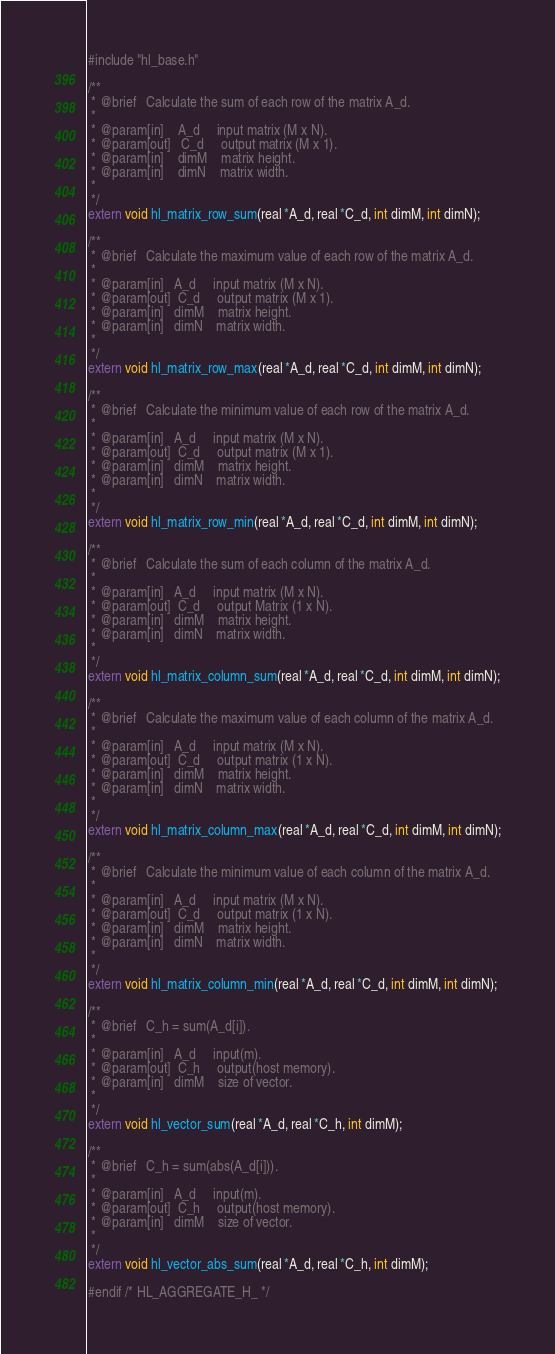Convert code to text. <code><loc_0><loc_0><loc_500><loc_500><_C_>#include "hl_base.h"

/**
 * @brief   Calculate the sum of each row of the matrix A_d.
 *
 * @param[in]    A_d     input matrix (M x N).
 * @param[out]   C_d     output matrix (M x 1).
 * @param[in]    dimM    matrix height.
 * @param[in]    dimN    matrix width.
 *
 */
extern void hl_matrix_row_sum(real *A_d, real *C_d, int dimM, int dimN);

/**
 * @brief   Calculate the maximum value of each row of the matrix A_d.
 *
 * @param[in]   A_d     input matrix (M x N).
 * @param[out]  C_d     output matrix (M x 1).
 * @param[in]   dimM    matrix height.
 * @param[in]   dimN    matrix width.
 *
 */
extern void hl_matrix_row_max(real *A_d, real *C_d, int dimM, int dimN);

/**
 * @brief   Calculate the minimum value of each row of the matrix A_d.
 *
 * @param[in]   A_d     input matrix (M x N).
 * @param[out]  C_d     output matrix (M x 1).
 * @param[in]   dimM    matrix height.
 * @param[in]   dimN    matrix width.
 *
 */
extern void hl_matrix_row_min(real *A_d, real *C_d, int dimM, int dimN);

/**
 * @brief   Calculate the sum of each column of the matrix A_d.
 *
 * @param[in]   A_d     input matrix (M x N).
 * @param[out]  C_d     output Matrix (1 x N).
 * @param[in]   dimM    matrix height.
 * @param[in]   dimN    matrix width.
 *
 */
extern void hl_matrix_column_sum(real *A_d, real *C_d, int dimM, int dimN);

/**
 * @brief   Calculate the maximum value of each column of the matrix A_d.
 *
 * @param[in]   A_d     input matrix (M x N).
 * @param[out]  C_d     output matrix (1 x N).
 * @param[in]   dimM    matrix height.
 * @param[in]   dimN    matrix width.
 *
 */
extern void hl_matrix_column_max(real *A_d, real *C_d, int dimM, int dimN);

/**
 * @brief   Calculate the minimum value of each column of the matrix A_d.
 *
 * @param[in]   A_d     input matrix (M x N).
 * @param[out]  C_d     output matrix (1 x N).
 * @param[in]   dimM    matrix height.
 * @param[in]   dimN    matrix width.
 *
 */
extern void hl_matrix_column_min(real *A_d, real *C_d, int dimM, int dimN);

/**
 * @brief   C_h = sum(A_d[i]).
 *
 * @param[in]   A_d     input(m).
 * @param[out]  C_h     output(host memory).
 * @param[in]   dimM    size of vector.
 *
 */
extern void hl_vector_sum(real *A_d, real *C_h, int dimM);

/**
 * @brief   C_h = sum(abs(A_d[i])).
 *
 * @param[in]   A_d     input(m).
 * @param[out]  C_h     output(host memory).
 * @param[in]   dimM    size of vector.
 *
 */
extern void hl_vector_abs_sum(real *A_d, real *C_h, int dimM);

#endif /* HL_AGGREGATE_H_ */
</code> 